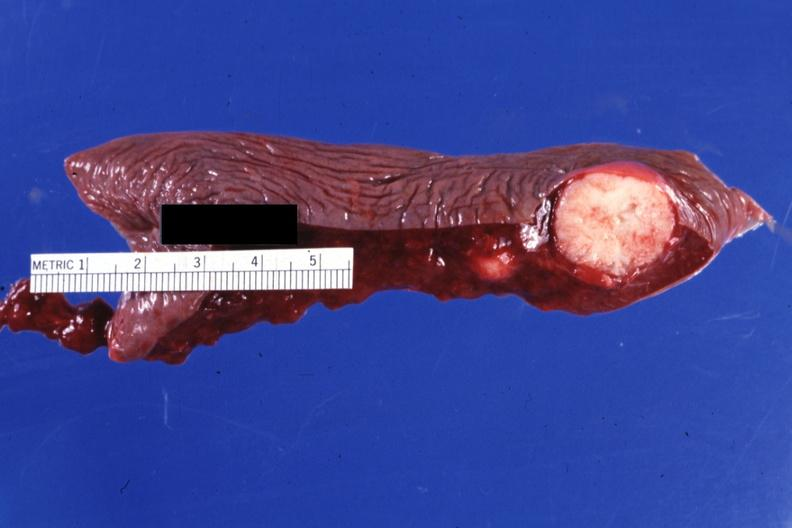s colon present?
Answer the question using a single word or phrase. No 